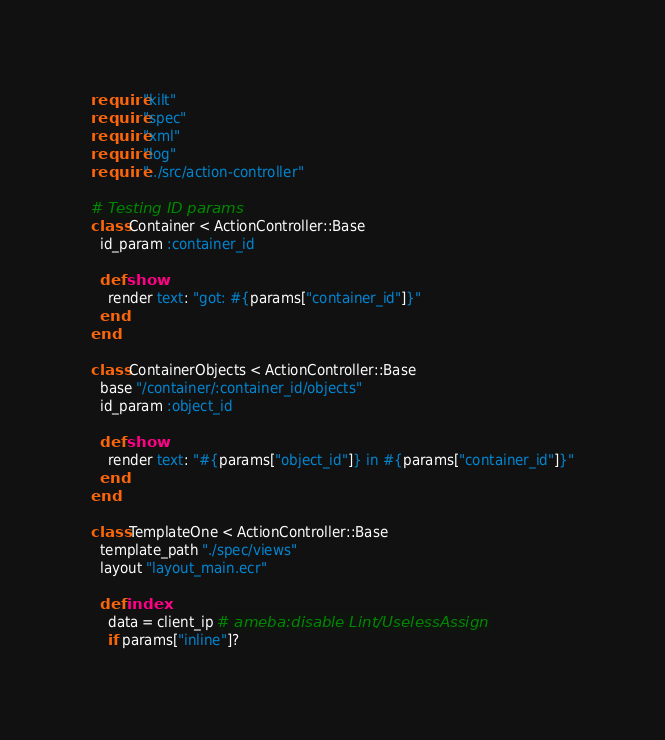<code> <loc_0><loc_0><loc_500><loc_500><_Crystal_>require "kilt"
require "spec"
require "xml"
require "log"
require "../src/action-controller"

# Testing ID params
class Container < ActionController::Base
  id_param :container_id

  def show
    render text: "got: #{params["container_id"]}"
  end
end

class ContainerObjects < ActionController::Base
  base "/container/:container_id/objects"
  id_param :object_id

  def show
    render text: "#{params["object_id"]} in #{params["container_id"]}"
  end
end

class TemplateOne < ActionController::Base
  template_path "./spec/views"
  layout "layout_main.ecr"

  def index
    data = client_ip # ameba:disable Lint/UselessAssign
    if params["inline"]?</code> 